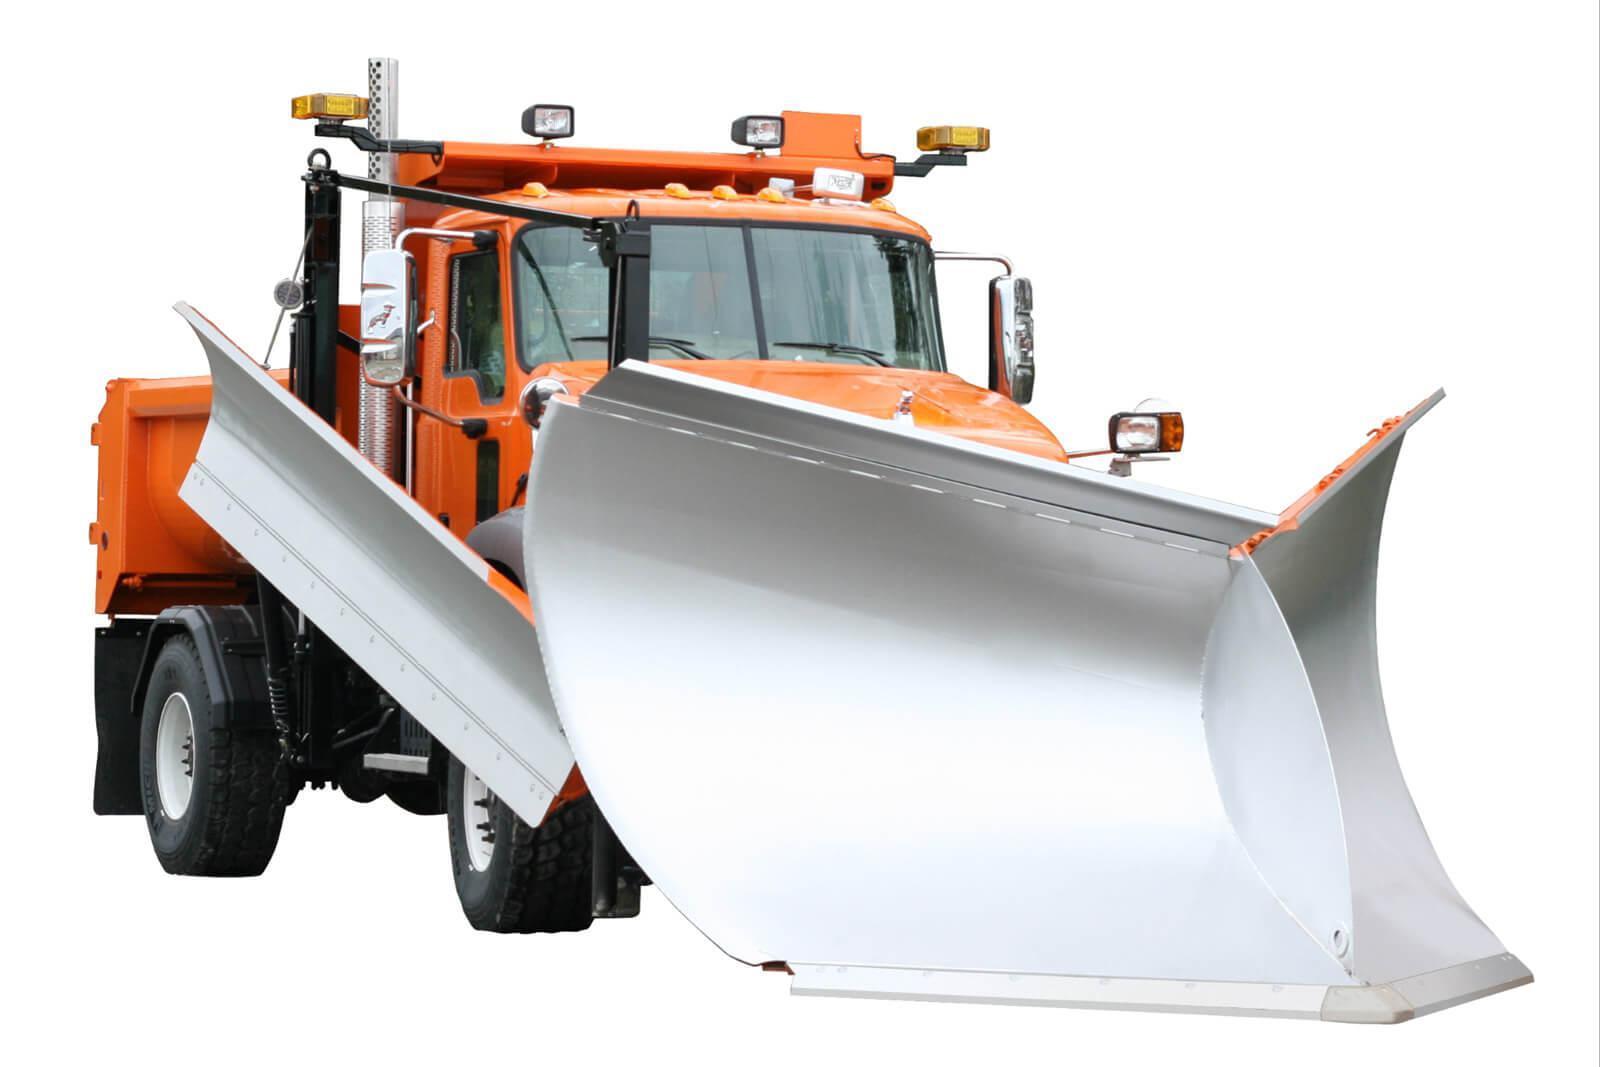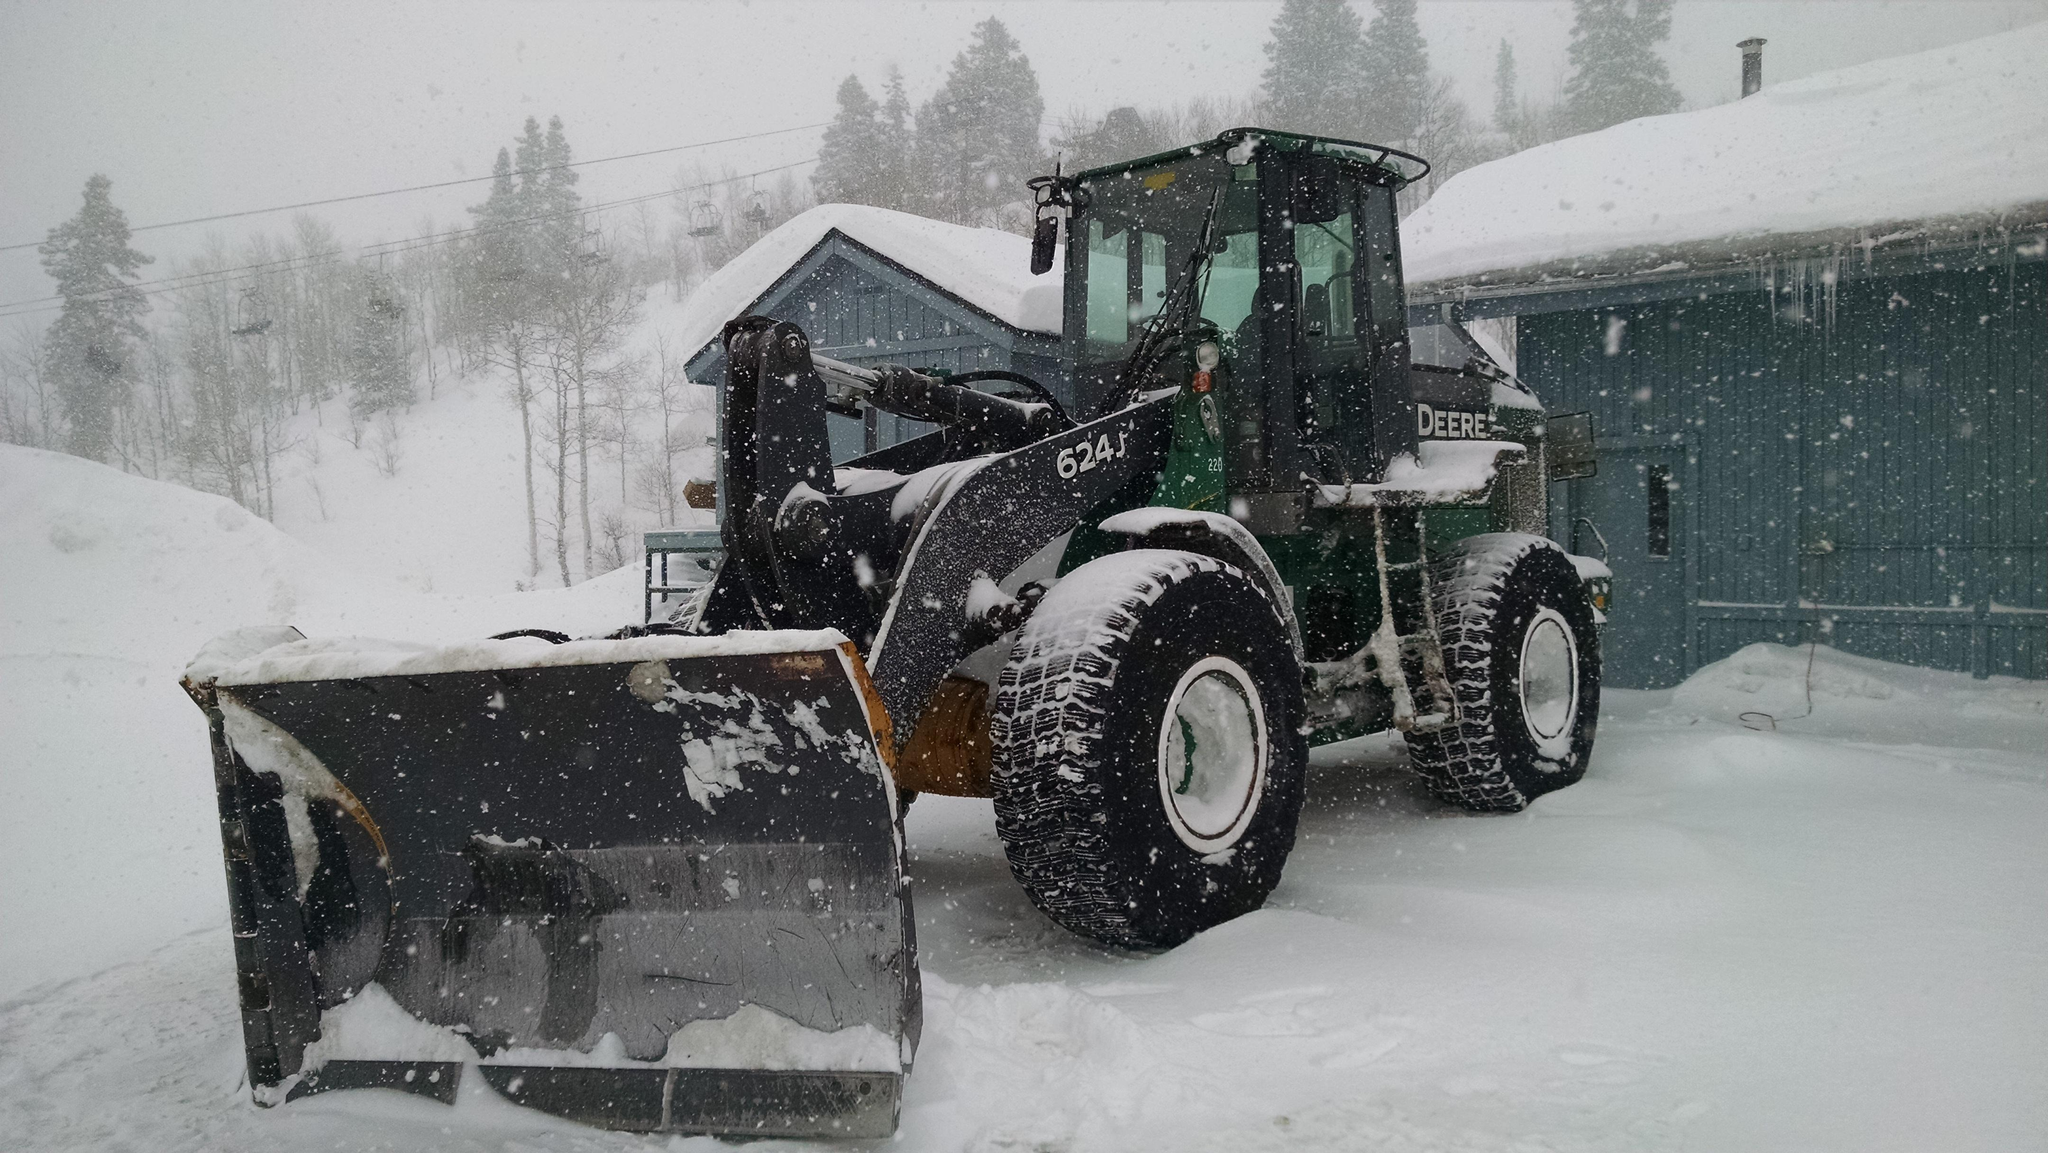The first image is the image on the left, the second image is the image on the right. For the images shown, is this caption "The left and right image contains the same number of yellow snow plows." true? Answer yes or no. No. 